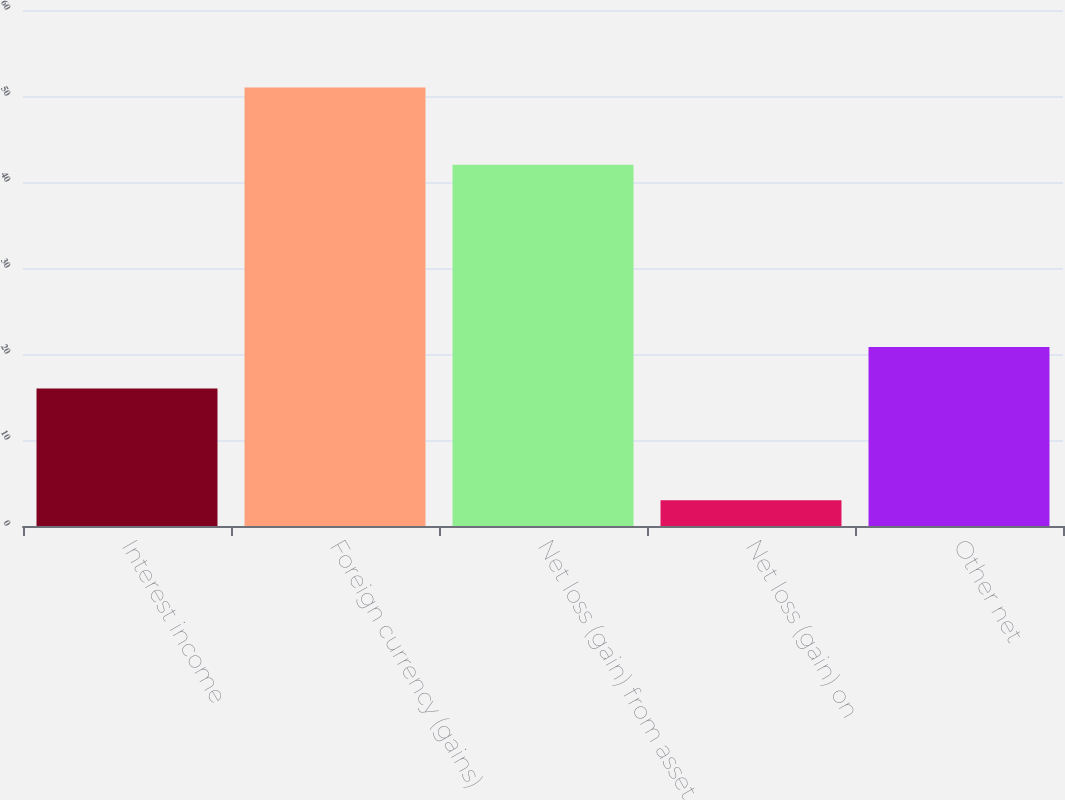<chart> <loc_0><loc_0><loc_500><loc_500><bar_chart><fcel>Interest income<fcel>Foreign currency (gains)<fcel>Net loss (gain) from asset<fcel>Net loss (gain) on<fcel>Other net<nl><fcel>16<fcel>51<fcel>42<fcel>3<fcel>20.8<nl></chart> 